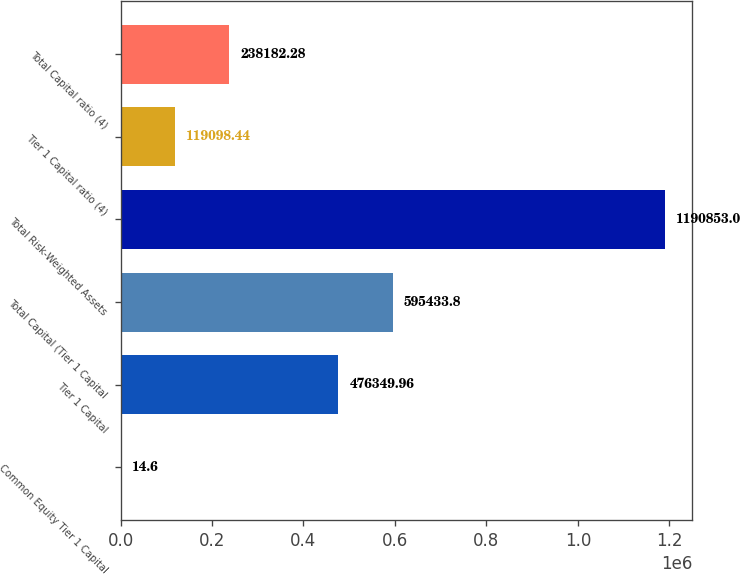<chart> <loc_0><loc_0><loc_500><loc_500><bar_chart><fcel>Common Equity Tier 1 Capital<fcel>Tier 1 Capital<fcel>Total Capital (Tier 1 Capital<fcel>Total Risk-Weighted Assets<fcel>Tier 1 Capital ratio (4)<fcel>Total Capital ratio (4)<nl><fcel>14.6<fcel>476350<fcel>595434<fcel>1.19085e+06<fcel>119098<fcel>238182<nl></chart> 